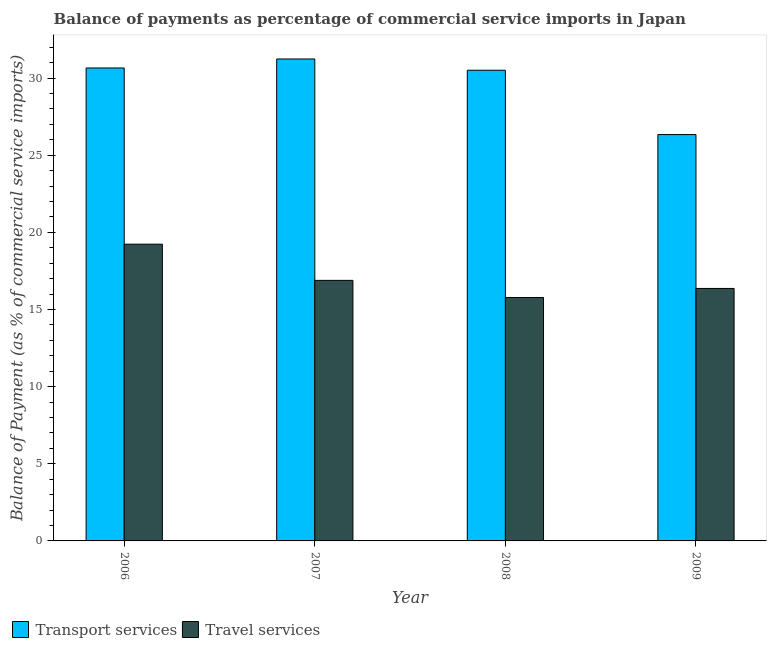What is the balance of payments of travel services in 2006?
Your response must be concise. 19.23. Across all years, what is the maximum balance of payments of transport services?
Offer a terse response. 31.23. Across all years, what is the minimum balance of payments of travel services?
Provide a short and direct response. 15.77. In which year was the balance of payments of travel services minimum?
Your response must be concise. 2008. What is the total balance of payments of travel services in the graph?
Your response must be concise. 68.26. What is the difference between the balance of payments of transport services in 2006 and that in 2008?
Give a very brief answer. 0.15. What is the difference between the balance of payments of travel services in 2006 and the balance of payments of transport services in 2007?
Offer a very short reply. 2.34. What is the average balance of payments of travel services per year?
Ensure brevity in your answer.  17.06. In the year 2008, what is the difference between the balance of payments of travel services and balance of payments of transport services?
Give a very brief answer. 0. In how many years, is the balance of payments of travel services greater than 28 %?
Offer a terse response. 0. What is the ratio of the balance of payments of travel services in 2006 to that in 2009?
Keep it short and to the point. 1.18. Is the balance of payments of travel services in 2007 less than that in 2009?
Offer a very short reply. No. Is the difference between the balance of payments of transport services in 2007 and 2009 greater than the difference between the balance of payments of travel services in 2007 and 2009?
Keep it short and to the point. No. What is the difference between the highest and the second highest balance of payments of transport services?
Keep it short and to the point. 0.58. What is the difference between the highest and the lowest balance of payments of transport services?
Make the answer very short. 4.9. In how many years, is the balance of payments of travel services greater than the average balance of payments of travel services taken over all years?
Your response must be concise. 1. Is the sum of the balance of payments of travel services in 2006 and 2007 greater than the maximum balance of payments of transport services across all years?
Offer a terse response. Yes. What does the 2nd bar from the left in 2007 represents?
Your response must be concise. Travel services. What does the 1st bar from the right in 2008 represents?
Your answer should be very brief. Travel services. What is the difference between two consecutive major ticks on the Y-axis?
Your answer should be compact. 5. Where does the legend appear in the graph?
Provide a succinct answer. Bottom left. What is the title of the graph?
Offer a terse response. Balance of payments as percentage of commercial service imports in Japan. What is the label or title of the Y-axis?
Provide a succinct answer. Balance of Payment (as % of commercial service imports). What is the Balance of Payment (as % of commercial service imports) in Transport services in 2006?
Offer a very short reply. 30.65. What is the Balance of Payment (as % of commercial service imports) of Travel services in 2006?
Give a very brief answer. 19.23. What is the Balance of Payment (as % of commercial service imports) in Transport services in 2007?
Ensure brevity in your answer.  31.23. What is the Balance of Payment (as % of commercial service imports) of Travel services in 2007?
Your response must be concise. 16.89. What is the Balance of Payment (as % of commercial service imports) of Transport services in 2008?
Keep it short and to the point. 30.5. What is the Balance of Payment (as % of commercial service imports) in Travel services in 2008?
Offer a very short reply. 15.77. What is the Balance of Payment (as % of commercial service imports) of Transport services in 2009?
Provide a short and direct response. 26.34. What is the Balance of Payment (as % of commercial service imports) in Travel services in 2009?
Your answer should be compact. 16.36. Across all years, what is the maximum Balance of Payment (as % of commercial service imports) of Transport services?
Your answer should be very brief. 31.23. Across all years, what is the maximum Balance of Payment (as % of commercial service imports) in Travel services?
Your response must be concise. 19.23. Across all years, what is the minimum Balance of Payment (as % of commercial service imports) in Transport services?
Provide a short and direct response. 26.34. Across all years, what is the minimum Balance of Payment (as % of commercial service imports) of Travel services?
Ensure brevity in your answer.  15.77. What is the total Balance of Payment (as % of commercial service imports) in Transport services in the graph?
Provide a succinct answer. 118.73. What is the total Balance of Payment (as % of commercial service imports) in Travel services in the graph?
Offer a very short reply. 68.26. What is the difference between the Balance of Payment (as % of commercial service imports) of Transport services in 2006 and that in 2007?
Offer a very short reply. -0.58. What is the difference between the Balance of Payment (as % of commercial service imports) of Travel services in 2006 and that in 2007?
Offer a terse response. 2.34. What is the difference between the Balance of Payment (as % of commercial service imports) of Transport services in 2006 and that in 2008?
Your answer should be compact. 0.15. What is the difference between the Balance of Payment (as % of commercial service imports) of Travel services in 2006 and that in 2008?
Your answer should be compact. 3.46. What is the difference between the Balance of Payment (as % of commercial service imports) of Transport services in 2006 and that in 2009?
Your answer should be very brief. 4.32. What is the difference between the Balance of Payment (as % of commercial service imports) of Travel services in 2006 and that in 2009?
Your response must be concise. 2.87. What is the difference between the Balance of Payment (as % of commercial service imports) of Transport services in 2007 and that in 2008?
Keep it short and to the point. 0.73. What is the difference between the Balance of Payment (as % of commercial service imports) of Travel services in 2007 and that in 2008?
Provide a short and direct response. 1.11. What is the difference between the Balance of Payment (as % of commercial service imports) in Transport services in 2007 and that in 2009?
Provide a succinct answer. 4.9. What is the difference between the Balance of Payment (as % of commercial service imports) in Travel services in 2007 and that in 2009?
Offer a very short reply. 0.52. What is the difference between the Balance of Payment (as % of commercial service imports) in Transport services in 2008 and that in 2009?
Your response must be concise. 4.17. What is the difference between the Balance of Payment (as % of commercial service imports) of Travel services in 2008 and that in 2009?
Provide a short and direct response. -0.59. What is the difference between the Balance of Payment (as % of commercial service imports) of Transport services in 2006 and the Balance of Payment (as % of commercial service imports) of Travel services in 2007?
Provide a succinct answer. 13.76. What is the difference between the Balance of Payment (as % of commercial service imports) in Transport services in 2006 and the Balance of Payment (as % of commercial service imports) in Travel services in 2008?
Make the answer very short. 14.88. What is the difference between the Balance of Payment (as % of commercial service imports) in Transport services in 2006 and the Balance of Payment (as % of commercial service imports) in Travel services in 2009?
Provide a short and direct response. 14.29. What is the difference between the Balance of Payment (as % of commercial service imports) of Transport services in 2007 and the Balance of Payment (as % of commercial service imports) of Travel services in 2008?
Your answer should be very brief. 15.46. What is the difference between the Balance of Payment (as % of commercial service imports) in Transport services in 2007 and the Balance of Payment (as % of commercial service imports) in Travel services in 2009?
Provide a short and direct response. 14.87. What is the difference between the Balance of Payment (as % of commercial service imports) in Transport services in 2008 and the Balance of Payment (as % of commercial service imports) in Travel services in 2009?
Ensure brevity in your answer.  14.14. What is the average Balance of Payment (as % of commercial service imports) of Transport services per year?
Provide a short and direct response. 29.68. What is the average Balance of Payment (as % of commercial service imports) in Travel services per year?
Your answer should be compact. 17.06. In the year 2006, what is the difference between the Balance of Payment (as % of commercial service imports) of Transport services and Balance of Payment (as % of commercial service imports) of Travel services?
Your response must be concise. 11.42. In the year 2007, what is the difference between the Balance of Payment (as % of commercial service imports) in Transport services and Balance of Payment (as % of commercial service imports) in Travel services?
Give a very brief answer. 14.35. In the year 2008, what is the difference between the Balance of Payment (as % of commercial service imports) of Transport services and Balance of Payment (as % of commercial service imports) of Travel services?
Give a very brief answer. 14.73. In the year 2009, what is the difference between the Balance of Payment (as % of commercial service imports) of Transport services and Balance of Payment (as % of commercial service imports) of Travel services?
Your response must be concise. 9.97. What is the ratio of the Balance of Payment (as % of commercial service imports) in Transport services in 2006 to that in 2007?
Your answer should be very brief. 0.98. What is the ratio of the Balance of Payment (as % of commercial service imports) of Travel services in 2006 to that in 2007?
Keep it short and to the point. 1.14. What is the ratio of the Balance of Payment (as % of commercial service imports) of Transport services in 2006 to that in 2008?
Your answer should be compact. 1. What is the ratio of the Balance of Payment (as % of commercial service imports) in Travel services in 2006 to that in 2008?
Give a very brief answer. 1.22. What is the ratio of the Balance of Payment (as % of commercial service imports) in Transport services in 2006 to that in 2009?
Ensure brevity in your answer.  1.16. What is the ratio of the Balance of Payment (as % of commercial service imports) in Travel services in 2006 to that in 2009?
Your response must be concise. 1.18. What is the ratio of the Balance of Payment (as % of commercial service imports) in Transport services in 2007 to that in 2008?
Offer a terse response. 1.02. What is the ratio of the Balance of Payment (as % of commercial service imports) in Travel services in 2007 to that in 2008?
Your response must be concise. 1.07. What is the ratio of the Balance of Payment (as % of commercial service imports) of Transport services in 2007 to that in 2009?
Offer a terse response. 1.19. What is the ratio of the Balance of Payment (as % of commercial service imports) of Travel services in 2007 to that in 2009?
Make the answer very short. 1.03. What is the ratio of the Balance of Payment (as % of commercial service imports) in Transport services in 2008 to that in 2009?
Offer a terse response. 1.16. What is the difference between the highest and the second highest Balance of Payment (as % of commercial service imports) in Transport services?
Offer a terse response. 0.58. What is the difference between the highest and the second highest Balance of Payment (as % of commercial service imports) of Travel services?
Your answer should be compact. 2.34. What is the difference between the highest and the lowest Balance of Payment (as % of commercial service imports) of Transport services?
Your answer should be very brief. 4.9. What is the difference between the highest and the lowest Balance of Payment (as % of commercial service imports) in Travel services?
Your response must be concise. 3.46. 